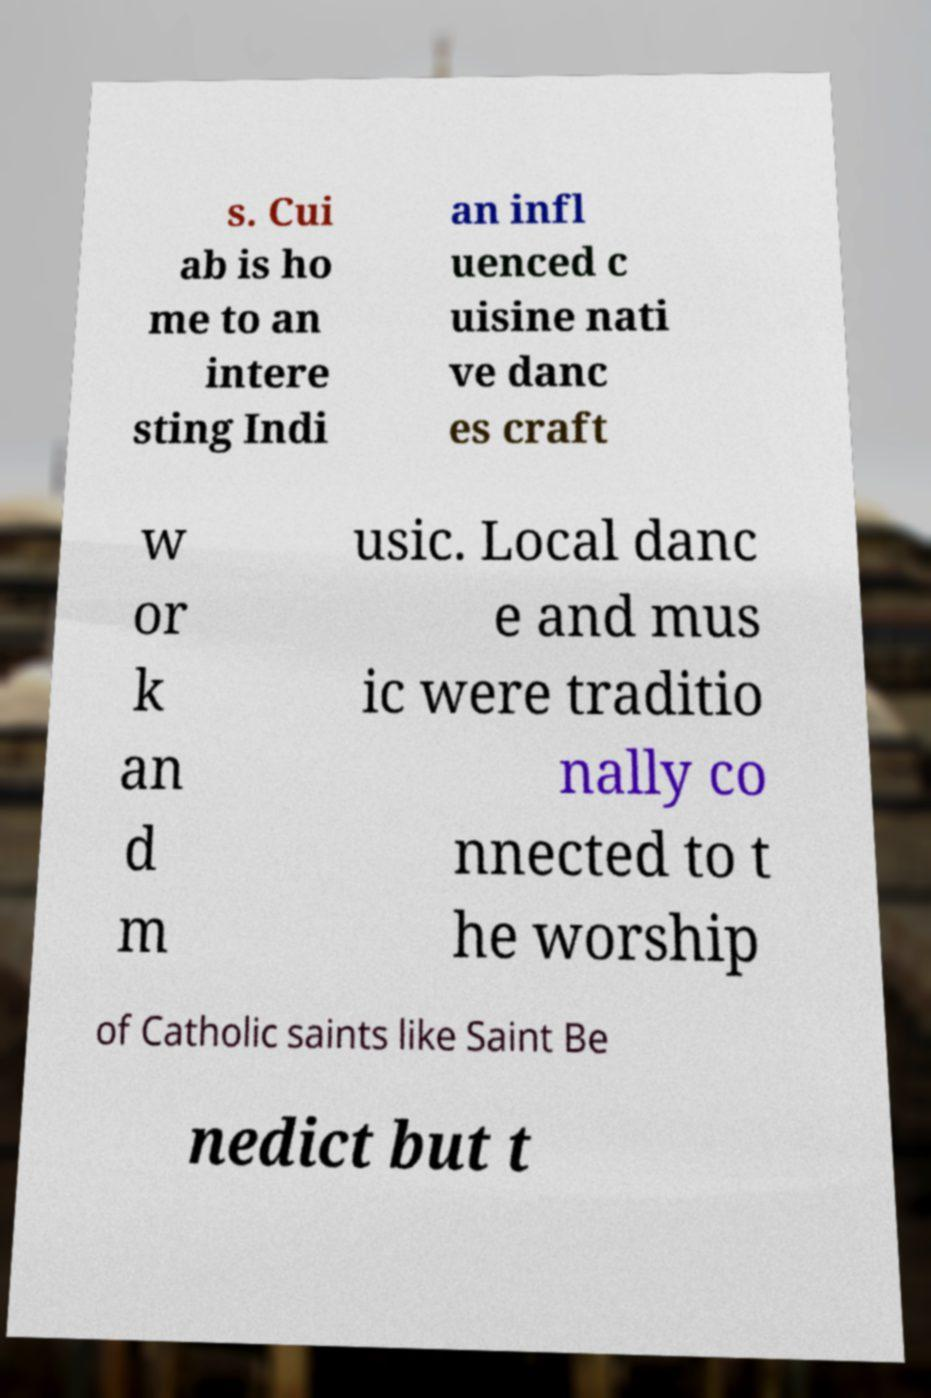I need the written content from this picture converted into text. Can you do that? s. Cui ab is ho me to an intere sting Indi an infl uenced c uisine nati ve danc es craft w or k an d m usic. Local danc e and mus ic were traditio nally co nnected to t he worship of Catholic saints like Saint Be nedict but t 